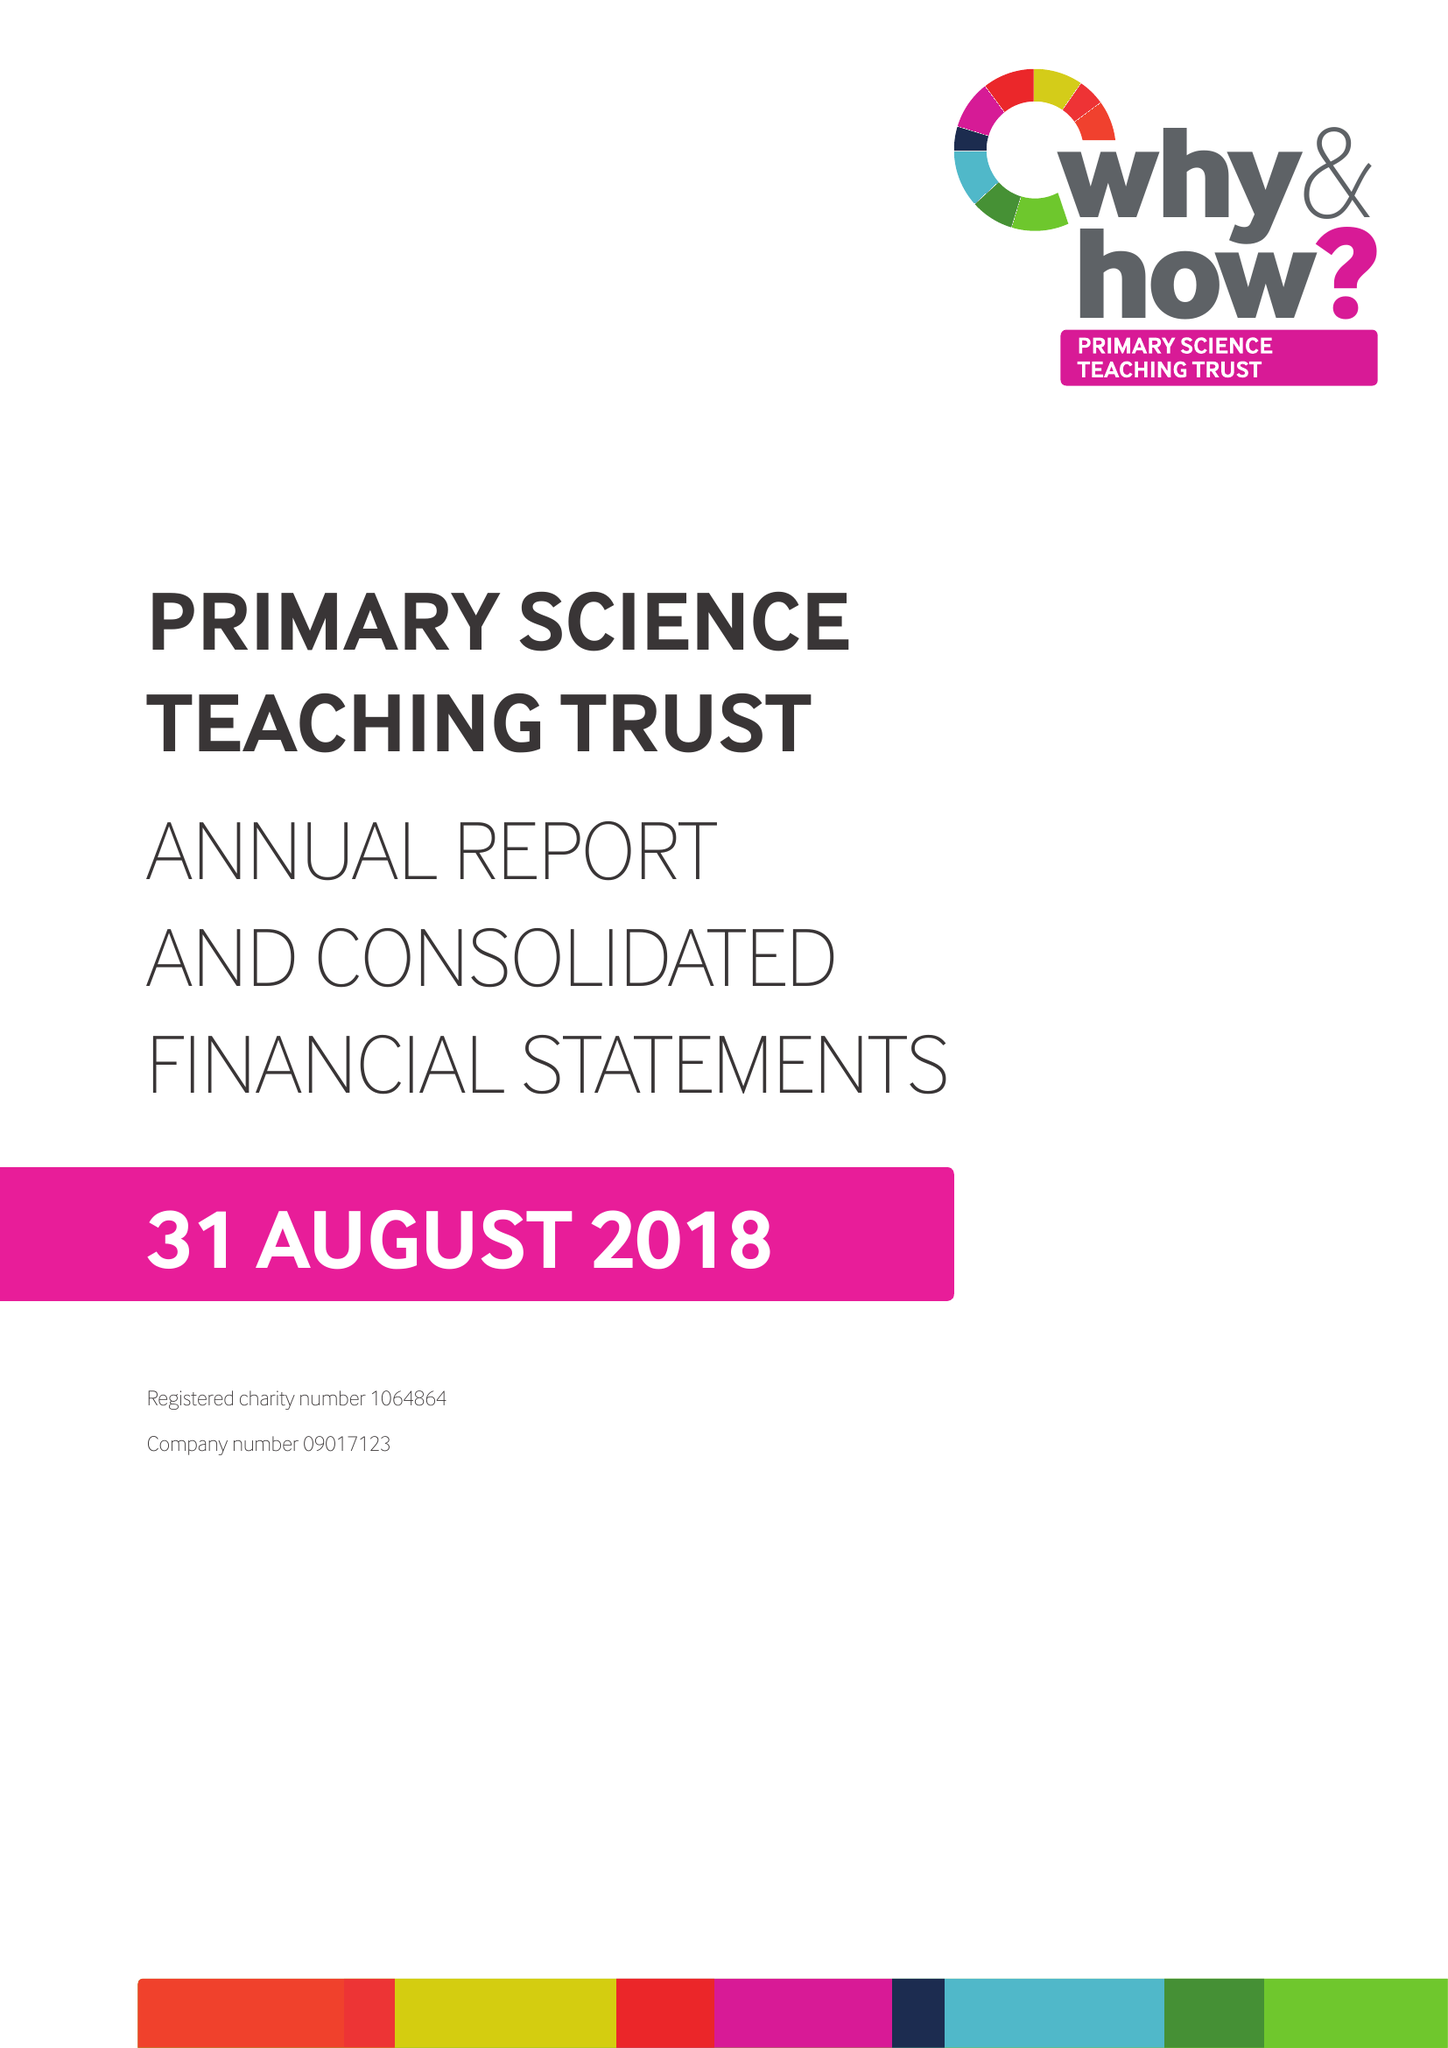What is the value for the income_annually_in_british_pounds?
Answer the question using a single word or phrase. 329557.00 